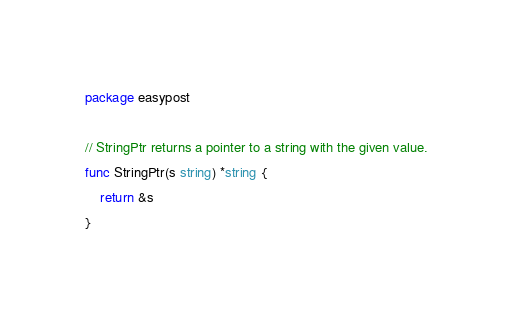<code> <loc_0><loc_0><loc_500><loc_500><_Go_>package easypost

// StringPtr returns a pointer to a string with the given value.
func StringPtr(s string) *string {
	return &s
}
</code> 